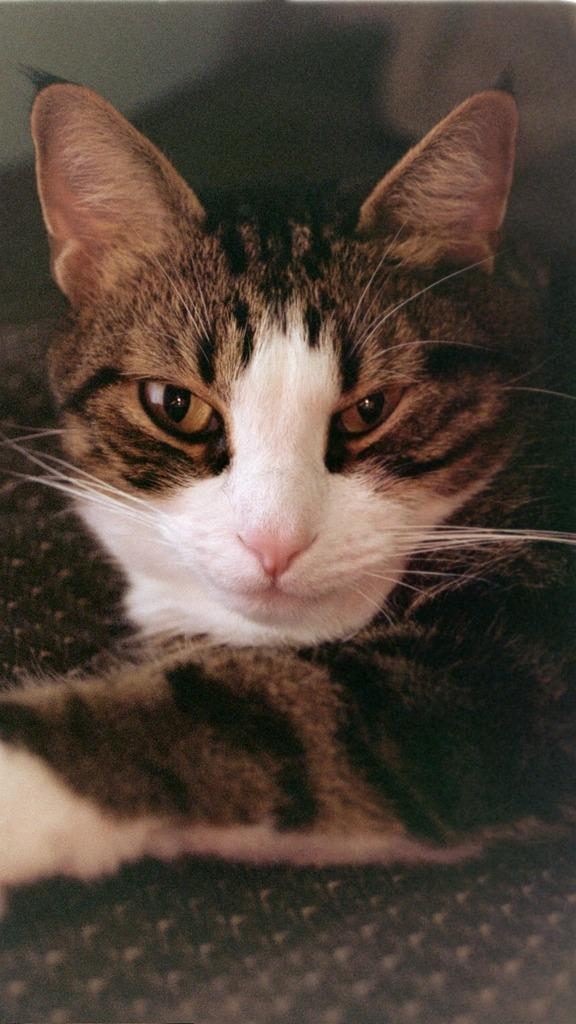What type of animal is present in the image? There is a cat in the image. What type of toad can be seen riding on the cat in the image? There is no toad present in the image, nor is there any indication that the cat is carrying a passenger. 